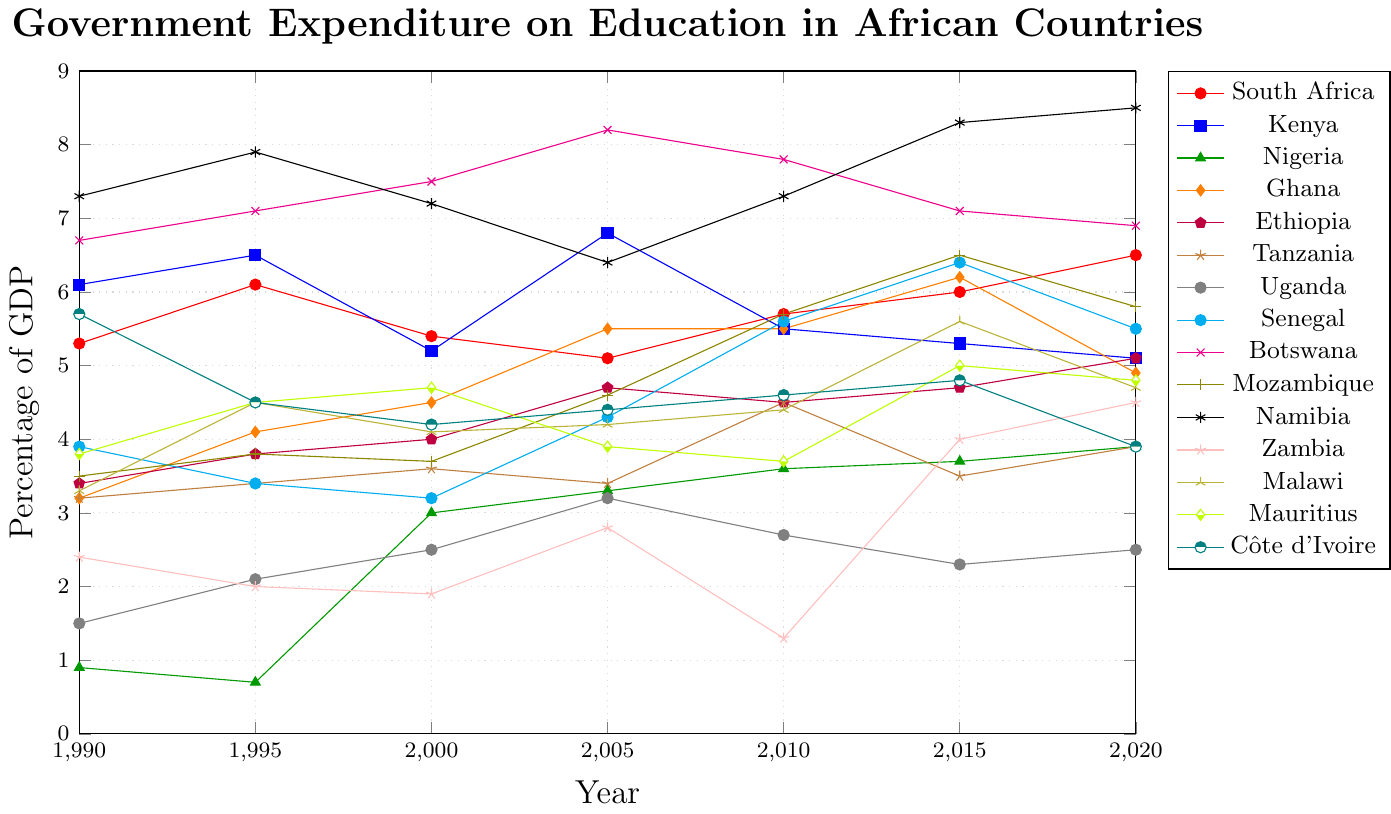What country had the highest percentage of GDP spent on education in 2020? From the plot, locate the highest line for the year 2020. This line corresponds to Namibia with a value of 8.5%.
Answer: Namibia How did the education expenditure percentages change for South Africa between 1990 and 2020? Identify the points for South Africa in 1990 and 2020 from the plot. In 1990, South Africa's expenditure was 5.3%, and in 2020, it was 6.5%. The change is 6.5% - 5.3%, which equals a 1.2% increase.
Answer: Increased by 1.2% Which country had the largest increase in education expenditure as a percentage of GDP from 1995 to 2000? For each country, calculate the difference between their 1995 and 2000 values from the plot, and identify the largest increase. Botswana increased from 7.1% to 7.5%, a 0.4% increase. Other countries either increased less or decreased.
Answer: Botswana In which year did Ghana have its highest expenditure percentage, and what was the value? By examining the trend line for Ghana, identify the peak value and the corresponding year. Ghana's highest expenditure was in 2015, with a value of 6.2%.
Answer: 2015 with 6.2% Compare the trends in education expenditure for Ethiopia and Tanzania from 2010 to 2020. Using the plot, analyze the lines of Ethiopia and Tanzania between 2010 and 2020. Ethiopia's expenditure increased from 4.5% to 5.1%, while Tanzania's expenditure fluctuated and slightly increased from 4.5% to 3.9%. Ethiopia's line shows a more consistent upward trend, whereas Tanzania's line is more variable and lower overall.
Answer: Ethiopia increased more consistently What was the difference in education expenditure percentages between Botswana and Côte d'Ivoire in 1990 and 2020 separately? For 1990: Botswana had 6.7% and Côte d'Ivoire had 5.7%, a difference of 6.7% - 5.7% = 1.0%. For 2020: Botswana had 6.9% and Côte d'Ivoire had 3.9%, a difference of 6.9% - 3.9% = 3.0%.
Answer: 1.0% in 1990, 3.0% in 2020 Which countries had a consistent upward trend in education expenditure as a percentage of GDP from 1990 to 2020? Review the plot and identify lines that continually rise from 1990 to 2020. Namibia consistently increases from 7.3% in 1990 to 8.5% in 2020.
Answer: Namibia What's the average education expenditure percentage for Kenya over the years provided? To find the average, sum Kenya's values (6.1 + 6.5 + 5.2 + 6.8 + 5.5 + 5.3 + 5.1) = 40.5 and divide by the number of years (7): 40.5 / 7 = 5.79.
Answer: 5.79% By how much did education expenditure percentage change in Mozambique between 2005 and 2015? Identify the values for Mozambique in 2005 and 2015 from the plot. In 2005, it was 4.6%; in 2015, it was 6.5%. The change is 6.5% - 4.6% = 1.9%.
Answer: Increased by 1.9% Which country had the lowest expenditure on education as a percentage of GDP in 1995? Find the point for 1995 with the lowest value; it corresponds to Nigeria with 0.7%.
Answer: Nigeria 